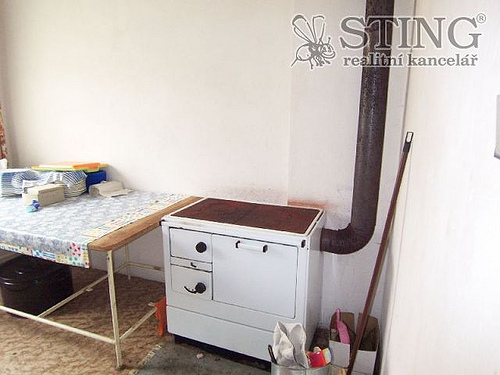Please transcribe the text in this image. STING realitni kancelar 